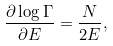Convert formula to latex. <formula><loc_0><loc_0><loc_500><loc_500>\frac { \partial \log { \Gamma } } { \partial E } = \frac { N } { 2 E } ,</formula> 